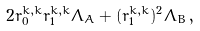<formula> <loc_0><loc_0><loc_500><loc_500>2 r _ { 0 } ^ { k , k } r _ { 1 } ^ { k , k } \Lambda _ { A } + ( r _ { 1 } ^ { k , k } ) ^ { 2 } \Lambda _ { B } \, ,</formula> 